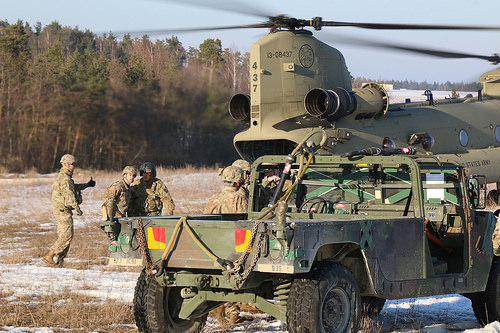<image>
Can you confirm if the man is to the left of the jeep? Yes. From this viewpoint, the man is positioned to the left side relative to the jeep. 